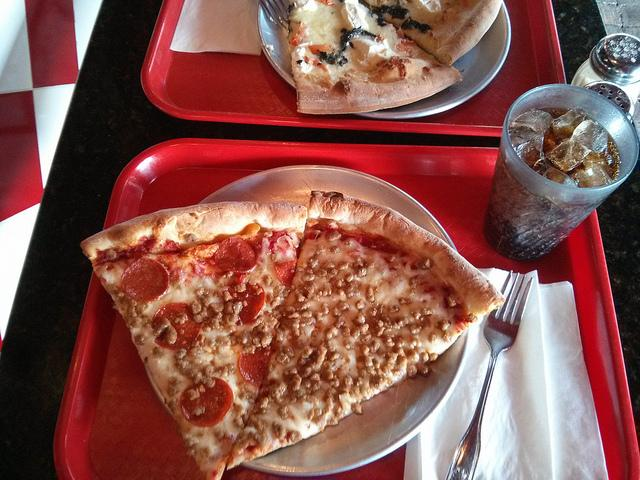Where was this pizza purchased?

Choices:
A) walmart
B) super market
C) home cooked
D) restaurant restaurant 